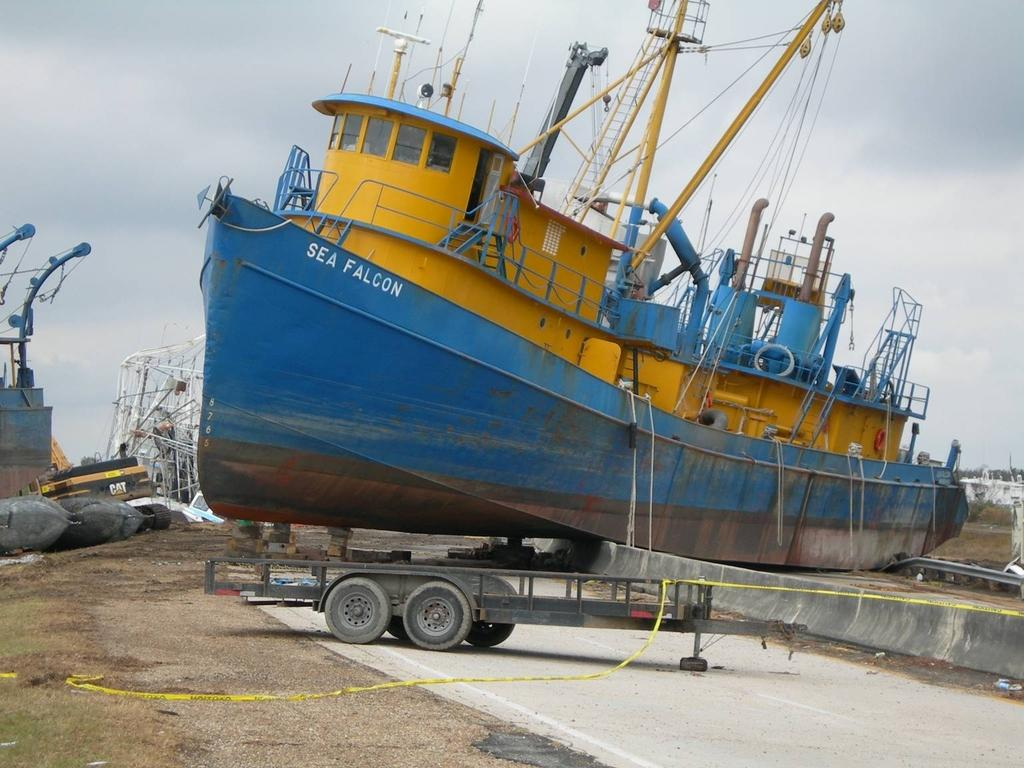<image>
Present a compact description of the photo's key features. A ship called the Sea Falcon has been run onto ground. 